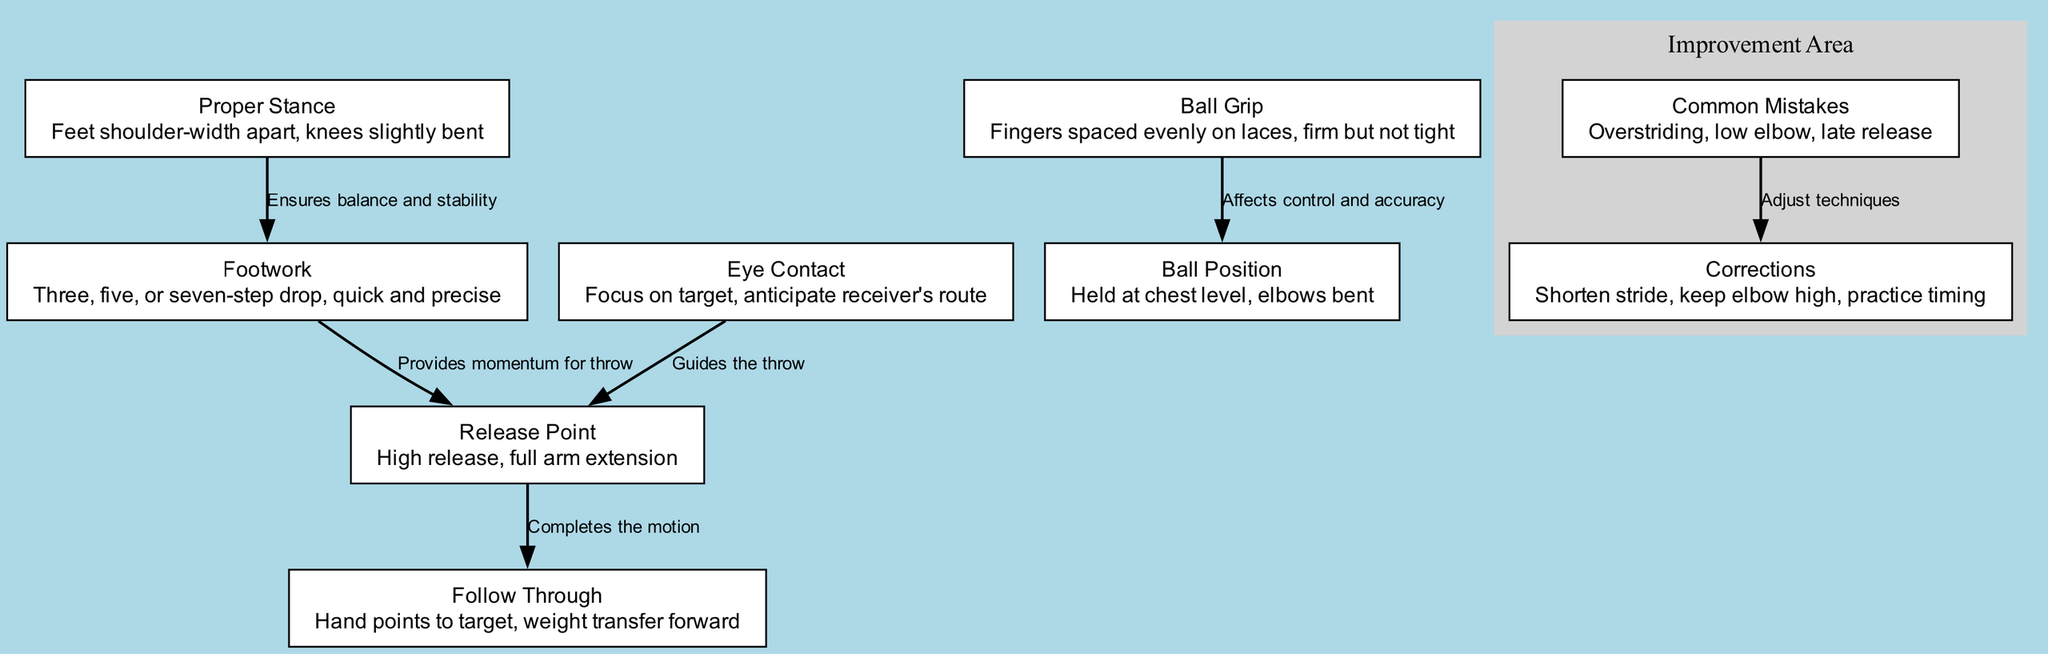What is the proper foot placement for the stance? The description of the "Proper Stance" node states that the feet should be shoulder-width apart. Since this is a fundamental aspect of the stance, it directly corresponds to the desired foot placement.
Answer: Feet shoulder-width apart How many nodes are present in the diagram? By counting the "nodes" section in the data, we find that there are 9 unique elements depicting various aspects of passing mechanics.
Answer: 9 What is the relationship between 'Grip' and 'Ball Position'? The diagram shows that the "Grip" affects the "Ball Position." This means that the way a quarterback grips the ball influences how the ball is positioned before the throw.
Answer: Affects control and accuracy What connects 'Footwork' to 'Release Point'? The diagram establishes a direct link between "Footwork" and "Release Point," indicating that proper footwork provides the necessary momentum needed for an effective throw.
Answer: Provides momentum for throw What should one focus on during eye contact? The node labeled "Eye Contact" indicates that one should focus on the target and anticipate the receiver's route. Thus, the key aspects to concentrate on are the target and the receiver's movement.
Answer: Focus on target, anticipate receiver's route What is a common mistake related to elbow positioning? The "Common Mistakes" node specifically mentions "low elbow" as one of the mistakes that can occur during the passing motion. Hence, the answer relates directly to elbow positioning.
Answer: Low elbow How can overstriding be corrected? According to the "Corrections" node, to address the issue of overstriding, one should shorten their stride. This is a direct corrective measure mentioned in the diagram.
Answer: Shorten stride What does the ‘Follow Through’ entail? The description of the "Follow Through" node states that it involves pointing the hand towards the target and transferring weight forward. This summarizes the actions involved during the follow-through phase.
Answer: Hand points to target, weight transfer forward 